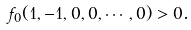<formula> <loc_0><loc_0><loc_500><loc_500>f _ { 0 } ( 1 , - 1 , 0 , 0 , \cdots , 0 ) > 0 .</formula> 